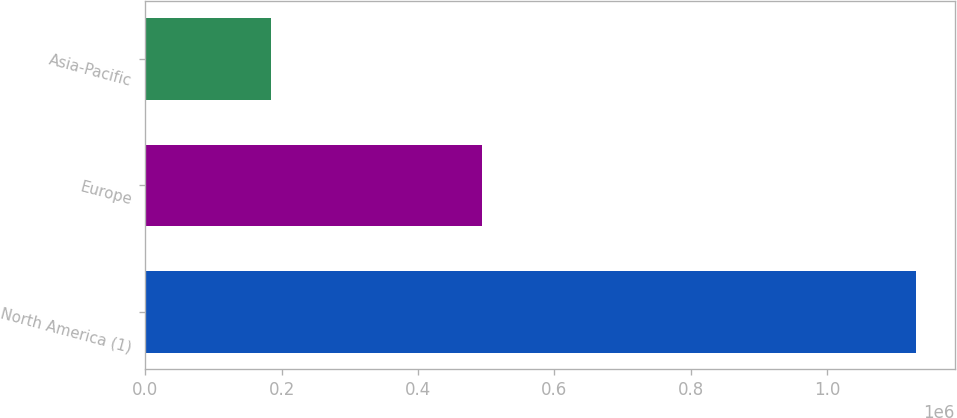Convert chart to OTSL. <chart><loc_0><loc_0><loc_500><loc_500><bar_chart><fcel>North America (1)<fcel>Europe<fcel>Asia-Pacific<nl><fcel>1.13064e+06<fcel>493492<fcel>183986<nl></chart> 